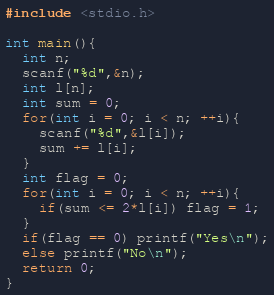<code> <loc_0><loc_0><loc_500><loc_500><_C_>#include <stdio.h>

int main(){
  int n;
  scanf("%d",&n);
  int l[n];
  int sum = 0;
  for(int i = 0; i < n; ++i){
    scanf("%d",&l[i]);
    sum += l[i];
  }
  int flag = 0;
  for(int i = 0; i < n; ++i){
    if(sum <= 2*l[i]) flag = 1;
  }
  if(flag == 0) printf("Yes\n");
  else printf("No\n");
  return 0;
}</code> 